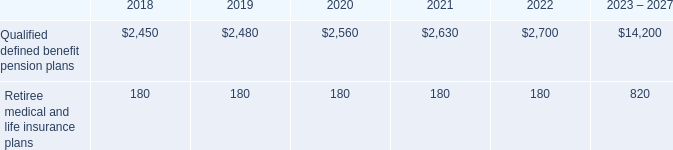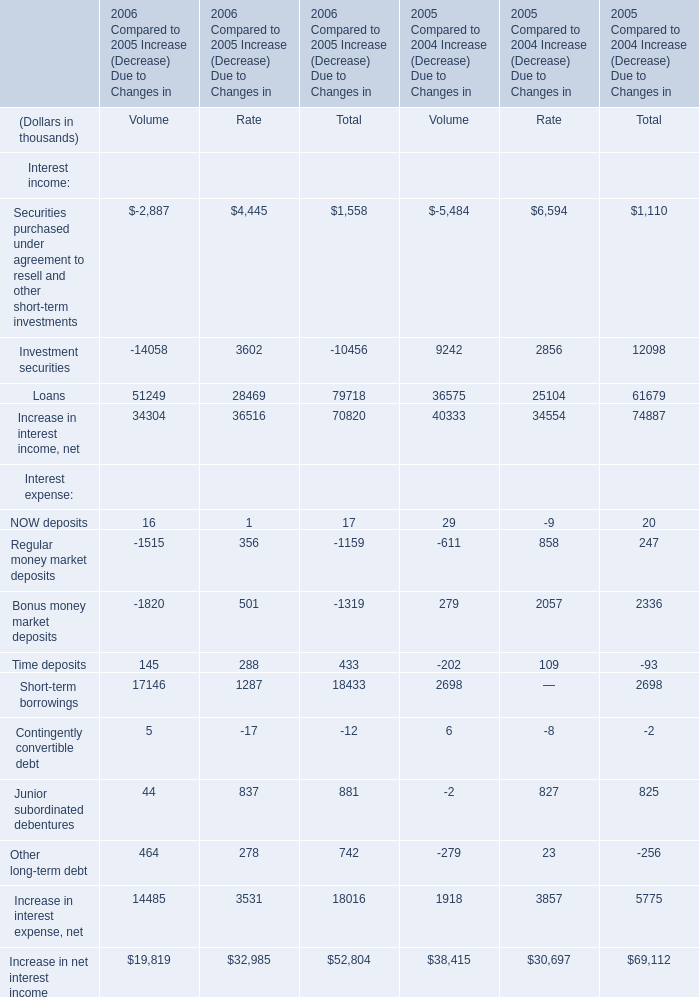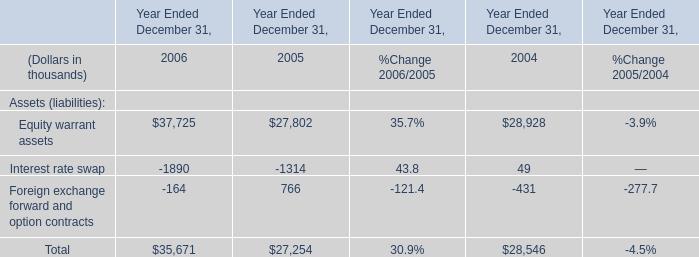What is the average amount of Equity warrant assets of Year Ended December 31, 2004, and Qualified defined benefit pension plans of 2022 ? 
Computations: ((28928.0 + 2700.0) / 2)
Answer: 15814.0. 